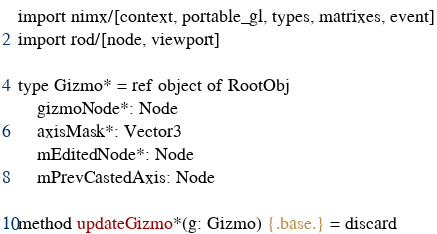Convert code to text. <code><loc_0><loc_0><loc_500><loc_500><_Nim_>import nimx/[context, portable_gl, types, matrixes, event]
import rod/[node, viewport]

type Gizmo* = ref object of RootObj
    gizmoNode*: Node
    axisMask*: Vector3
    mEditedNode*: Node
    mPrevCastedAxis: Node

method updateGizmo*(g: Gizmo) {.base.} = discard</code> 